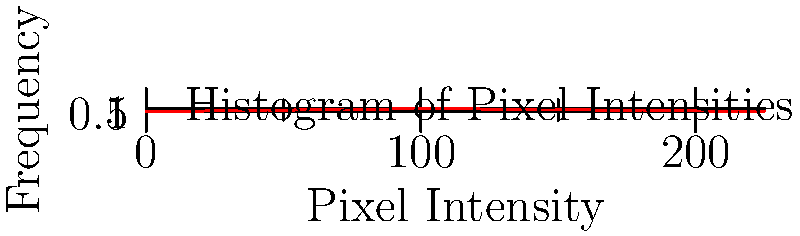As a photographer challenging societal beauty standards with raw, unedited images, you've captured a portrait in low-light conditions. The histogram of pixel intensities for this image is shown above. If you were to increase the exposure by 1 stop (doubling the light), how would the mean pixel intensity change, assuming a linear response? Express your answer as a percentage increase. To solve this problem, we need to follow these steps:

1. Understand the concept of stops in photography:
   - Increasing exposure by 1 stop means doubling the amount of light.

2. Analyze the current histogram:
   - The x-axis represents pixel intensities from 0 to 225.
   - The y-axis represents the frequency of each intensity.

3. Calculate the current mean pixel intensity:
   - We can estimate the mean by finding the weighted average of the intensities.
   - Using the midpoints of each bin and the corresponding frequencies:
     $$(12.5 \times 0.1 + 37.5 \times 0.2 + 62.5 \times 0.5 + 87.5 \times 0.8 + 112.5 \times 1.0 + 137.5 \times 0.9 + 162.5 \times 0.7 + 187.5 \times 0.4 + 212.5 \times 0.2 + 237.5 \times 0.1) \div (0.1 + 0.2 + 0.5 + 0.8 + 1.0 + 0.9 + 0.7 + 0.4 + 0.2 + 0.1) \approx 112.5$$

4. Calculate the new mean pixel intensity after increasing exposure by 1 stop:
   - Doubling the light means doubling the pixel intensities.
   - New mean = $112.5 \times 2 = 225$

5. Calculate the percentage increase:
   - Percentage increase = $\frac{\text{Increase}}{\text{Original}} \times 100\%$
   - $\frac{225 - 112.5}{112.5} \times 100\% = 100\%$

Therefore, increasing the exposure by 1 stop would result in a 100% increase in the mean pixel intensity.
Answer: 100% 